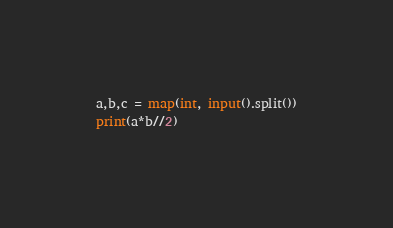<code> <loc_0><loc_0><loc_500><loc_500><_Python_>a,b,c = map(int, input().split())
print(a*b//2)</code> 